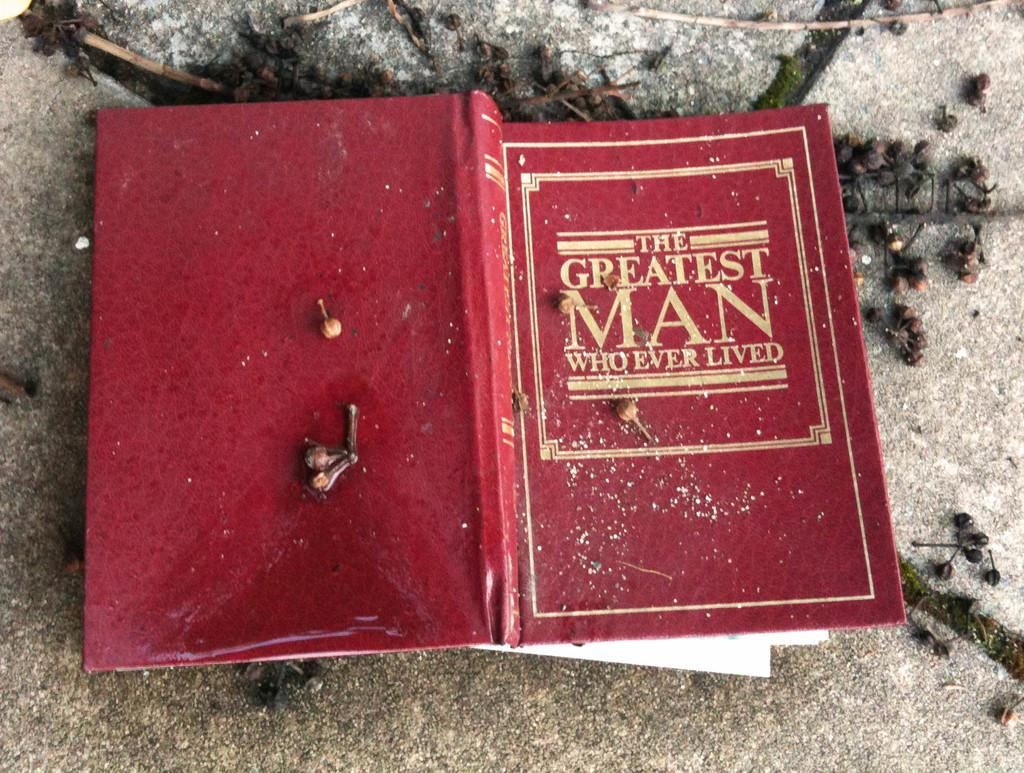<image>
Offer a succinct explanation of the picture presented. The greatest man who ever lived chapter book 